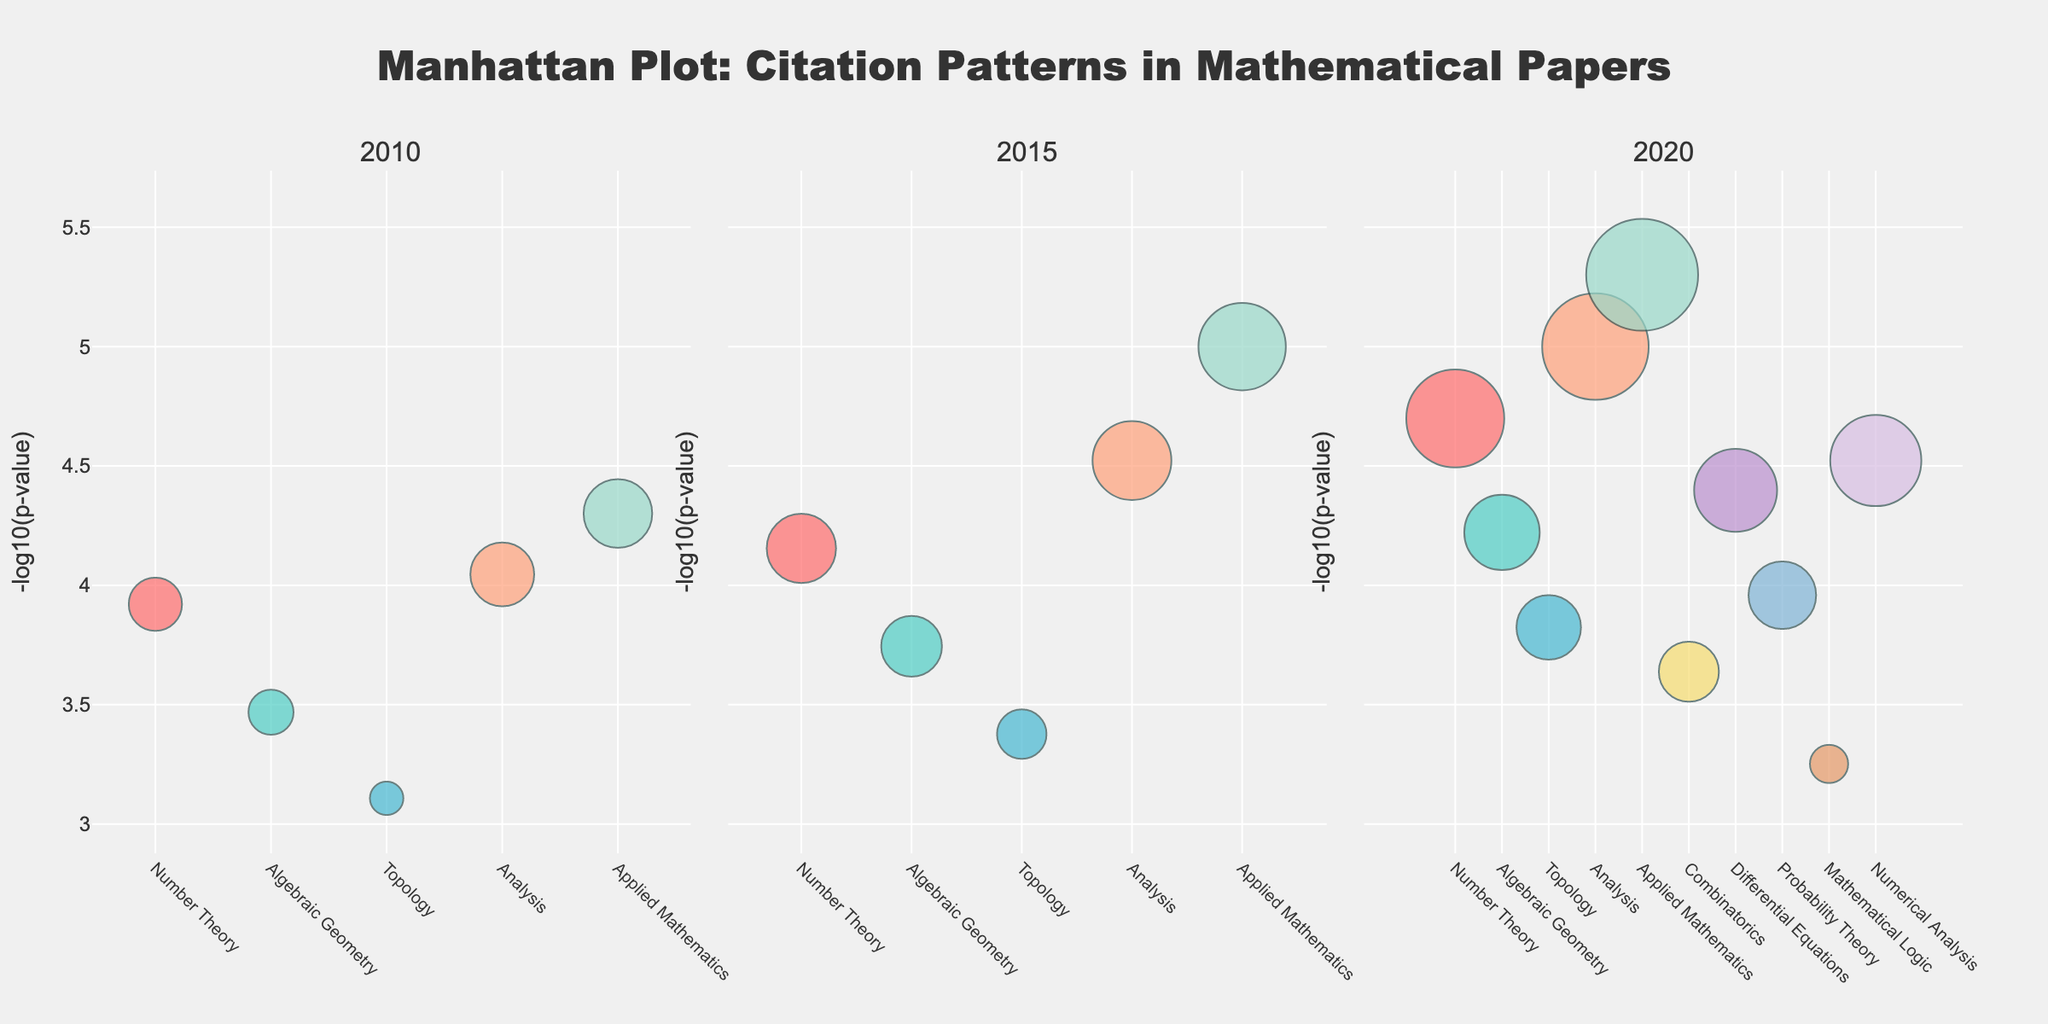What's the title of the plot? The title of the plot is at the top center of the figure. It reads "Manhattan Plot: Citation Patterns in Mathematical Papers".
Answer: Manhattan Plot: Citation Patterns in Mathematical Papers What is represented on the x-axis and y-axis of the plot? The x-axis represents the subfields of mathematics, and the y-axis represents the negative logarithm of the p-values of the citation counts (-log10(p-value)).
Answer: x-axis: subfields of mathematics; y-axis: -log10(p-value) Which subfield had the highest citation count in 2010? In the subplot labeled 2010, look for the subfield with the largest marker size, which represents the highest citation count. The largest marker is for Applied Mathematics.
Answer: Applied Mathematics Between 2015 and 2020, which subfield saw the largest increase in citation count? Compare the sizes of the markers in the 2015 and 2020 subplots to find the subfield with the largest increase in marker size. Applied Mathematics shows a significant increase from 201 to 328 citations.
Answer: Applied Mathematics In which year did Analysis show the most significant p-value (smallest p-value)? Look for Analysis in each subplot and find which year has the highest -log10(p-value). The highest value is in 2020.
Answer: 2020 What's the average -log10(p-value) for Applied Mathematics across all years? Determine the -log10(p-value) for Applied Mathematics in each year (2010, 2015, 2020), then calculate the average. Values: 4.30 (2010), 5.00 (2015), 5.30 (2020). Average = (4.30 + 5.00 + 5.30) / 3 = 4.87.
Answer: 4.87 How many subfields are represented in the year 2020? Count the number of markers in the 2020 subplot. There are 10 different subfields shown.
Answer: 10 Which subfield in 2015 had fewer citations than Algebraic Geometry but higher -log10(p-value)? In the 2015 subplot, look for markers smaller than Algebraic Geometry (citations: 178, -log10(p-value): 3.74) but placed higher on the y-axis. No subfield fits these criteria; none have higher -log10(p-value) but lower citation counts.
Answer: None Which subfield had the lowest -log10(p-value) in 2020, and what is its value? In the 2020 subplot, find the subfield with the smallest -log10(p-value). Mathematical Logic has the lowest at approximately 3.25.
Answer: Mathematical Logic, 3.25 